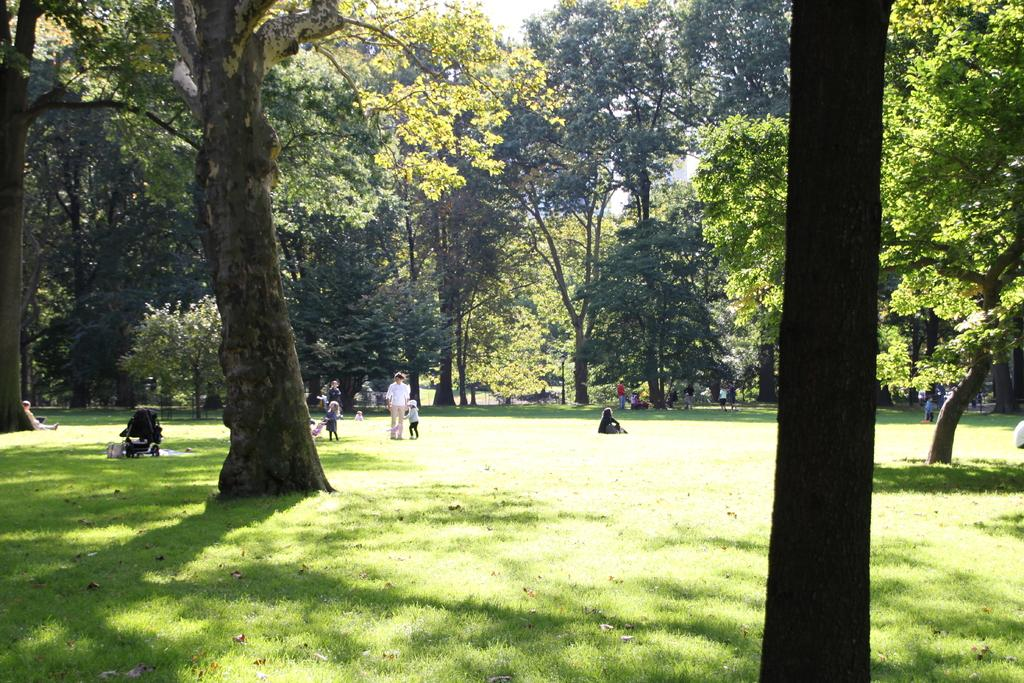What is happening on the ground in the image? There are people on the ground in the image. Can you describe the clothing of the people in the image? The people are wearing different color dresses. What can be seen in the background of the image? There are many trees in the background of the image. What is the color of the sky in the image? The sky is white in the image. What type of zinc is being used to cook the food in the image? There is no zinc or cooking activity present in the image. Can you tell me how many balls are visible in the image? There are no balls present in the image. 